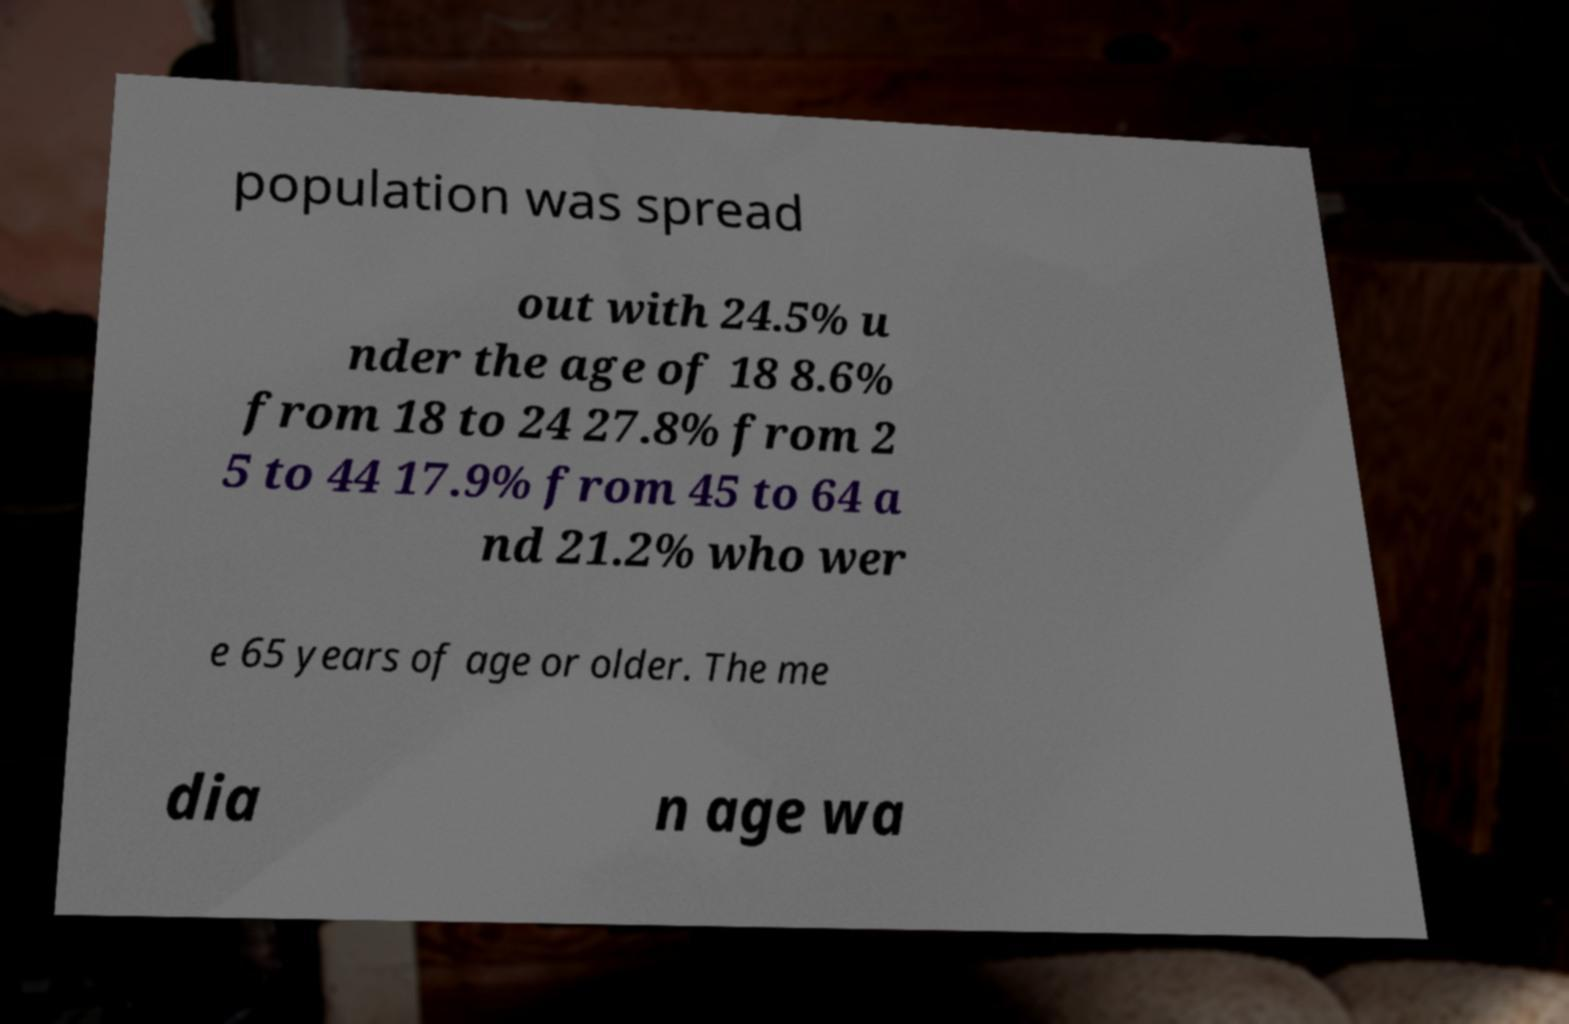What messages or text are displayed in this image? I need them in a readable, typed format. population was spread out with 24.5% u nder the age of 18 8.6% from 18 to 24 27.8% from 2 5 to 44 17.9% from 45 to 64 a nd 21.2% who wer e 65 years of age or older. The me dia n age wa 